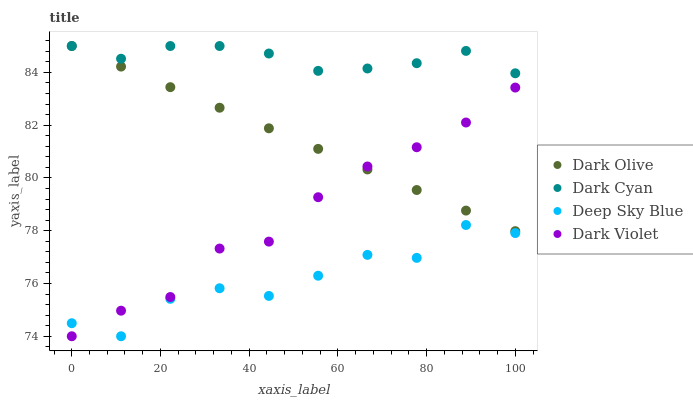Does Deep Sky Blue have the minimum area under the curve?
Answer yes or no. Yes. Does Dark Cyan have the maximum area under the curve?
Answer yes or no. Yes. Does Dark Olive have the minimum area under the curve?
Answer yes or no. No. Does Dark Olive have the maximum area under the curve?
Answer yes or no. No. Is Dark Olive the smoothest?
Answer yes or no. Yes. Is Deep Sky Blue the roughest?
Answer yes or no. Yes. Is Dark Violet the smoothest?
Answer yes or no. No. Is Dark Violet the roughest?
Answer yes or no. No. Does Dark Violet have the lowest value?
Answer yes or no. Yes. Does Dark Olive have the lowest value?
Answer yes or no. No. Does Dark Olive have the highest value?
Answer yes or no. Yes. Does Dark Violet have the highest value?
Answer yes or no. No. Is Dark Violet less than Dark Cyan?
Answer yes or no. Yes. Is Dark Cyan greater than Dark Violet?
Answer yes or no. Yes. Does Deep Sky Blue intersect Dark Violet?
Answer yes or no. Yes. Is Deep Sky Blue less than Dark Violet?
Answer yes or no. No. Is Deep Sky Blue greater than Dark Violet?
Answer yes or no. No. Does Dark Violet intersect Dark Cyan?
Answer yes or no. No. 